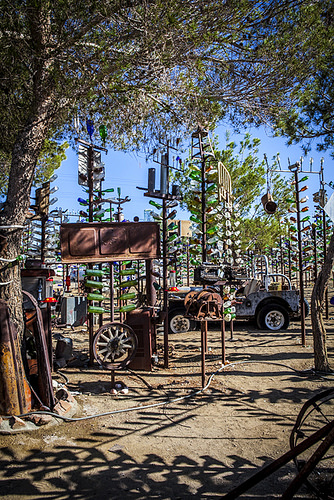<image>
Is the car next to the tree? Yes. The car is positioned adjacent to the tree, located nearby in the same general area. 